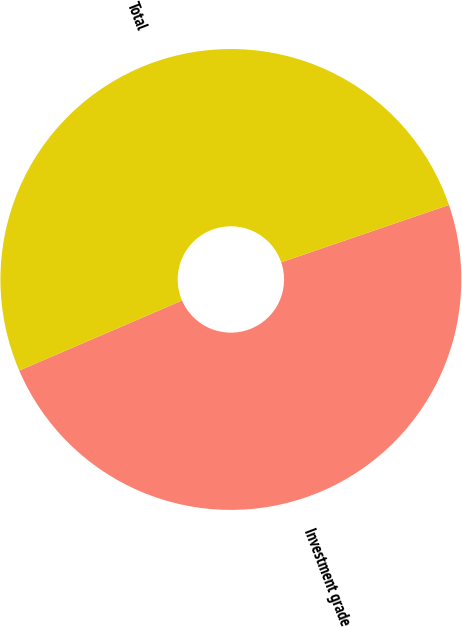Convert chart to OTSL. <chart><loc_0><loc_0><loc_500><loc_500><pie_chart><fcel>Investment grade<fcel>Total<nl><fcel>48.77%<fcel>51.23%<nl></chart> 